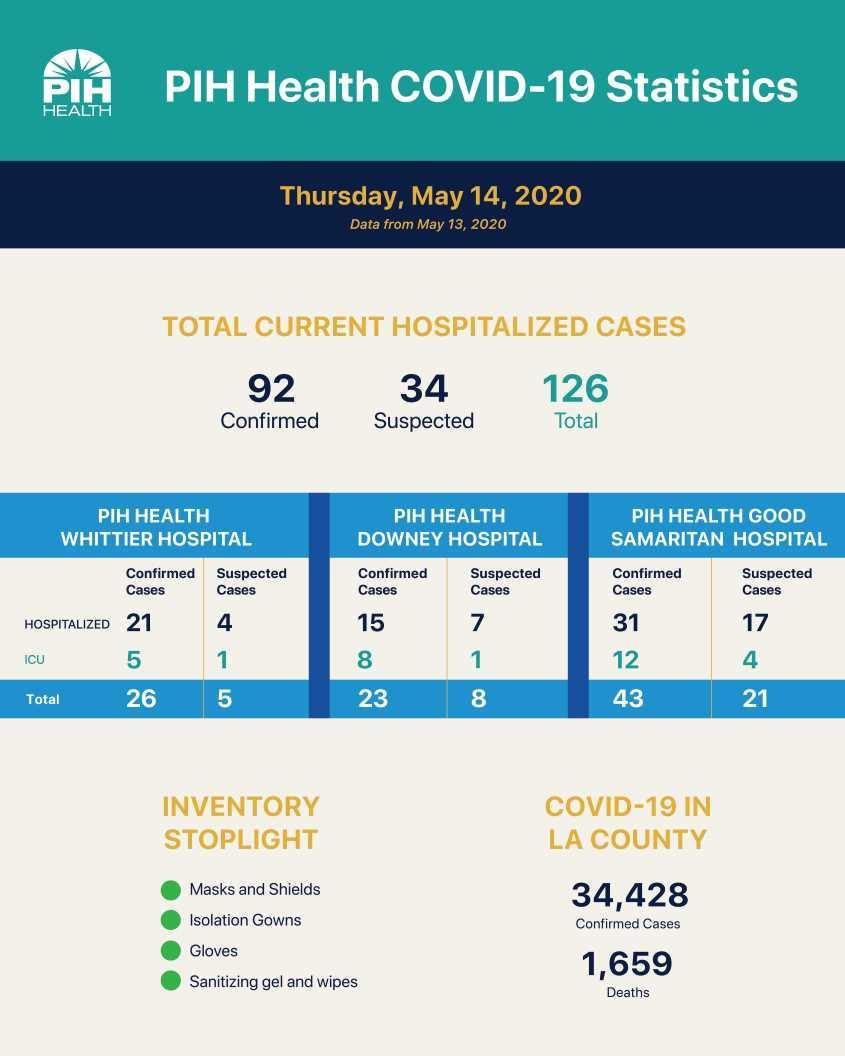How many confirmed COVID-19 cases were hospitalised in the PIH Health Good Samaritan hospital as of May 14, 2020?
Answer the question with a short phrase. 31 What is the total number of suspected COVID-19 cases reported in PIH Health Downey hospital as of May 14, 2020? 8 What is the total number of confirmed COVID-19 cases reported in PIH Health Whittier hospital as of May 14, 2020? 26 How many suspected COVID-19 cases were hospitalised in the ICU in PIH Health Downey hospital as of May 14, 2020? 1 How many suspected COVID-19 cases were hospitalised in the ICU in PIH Health Good Samaritan hospital as of May 14, 2020? 4 What is the number of COVID-19 deaths in the LA county as of May 14, 2020? 1,659 What is the total number of suspected COVID-19 cases reported in PIH Health Whittier hospital as of May 14, 2020? 5 How many confirmed COVID-19 cases were hospitalised in the PIH Health Downey hospital as of May 14, 2020? 15 What is the total number of suspected COVID-19 cases reported in PIH Health Good Samaritan hospital as of May 14, 2020? 21 What is the total number of confirmed COVID-19 cases reported in PIH Health Downey hospital as of May 14, 2020? 23 